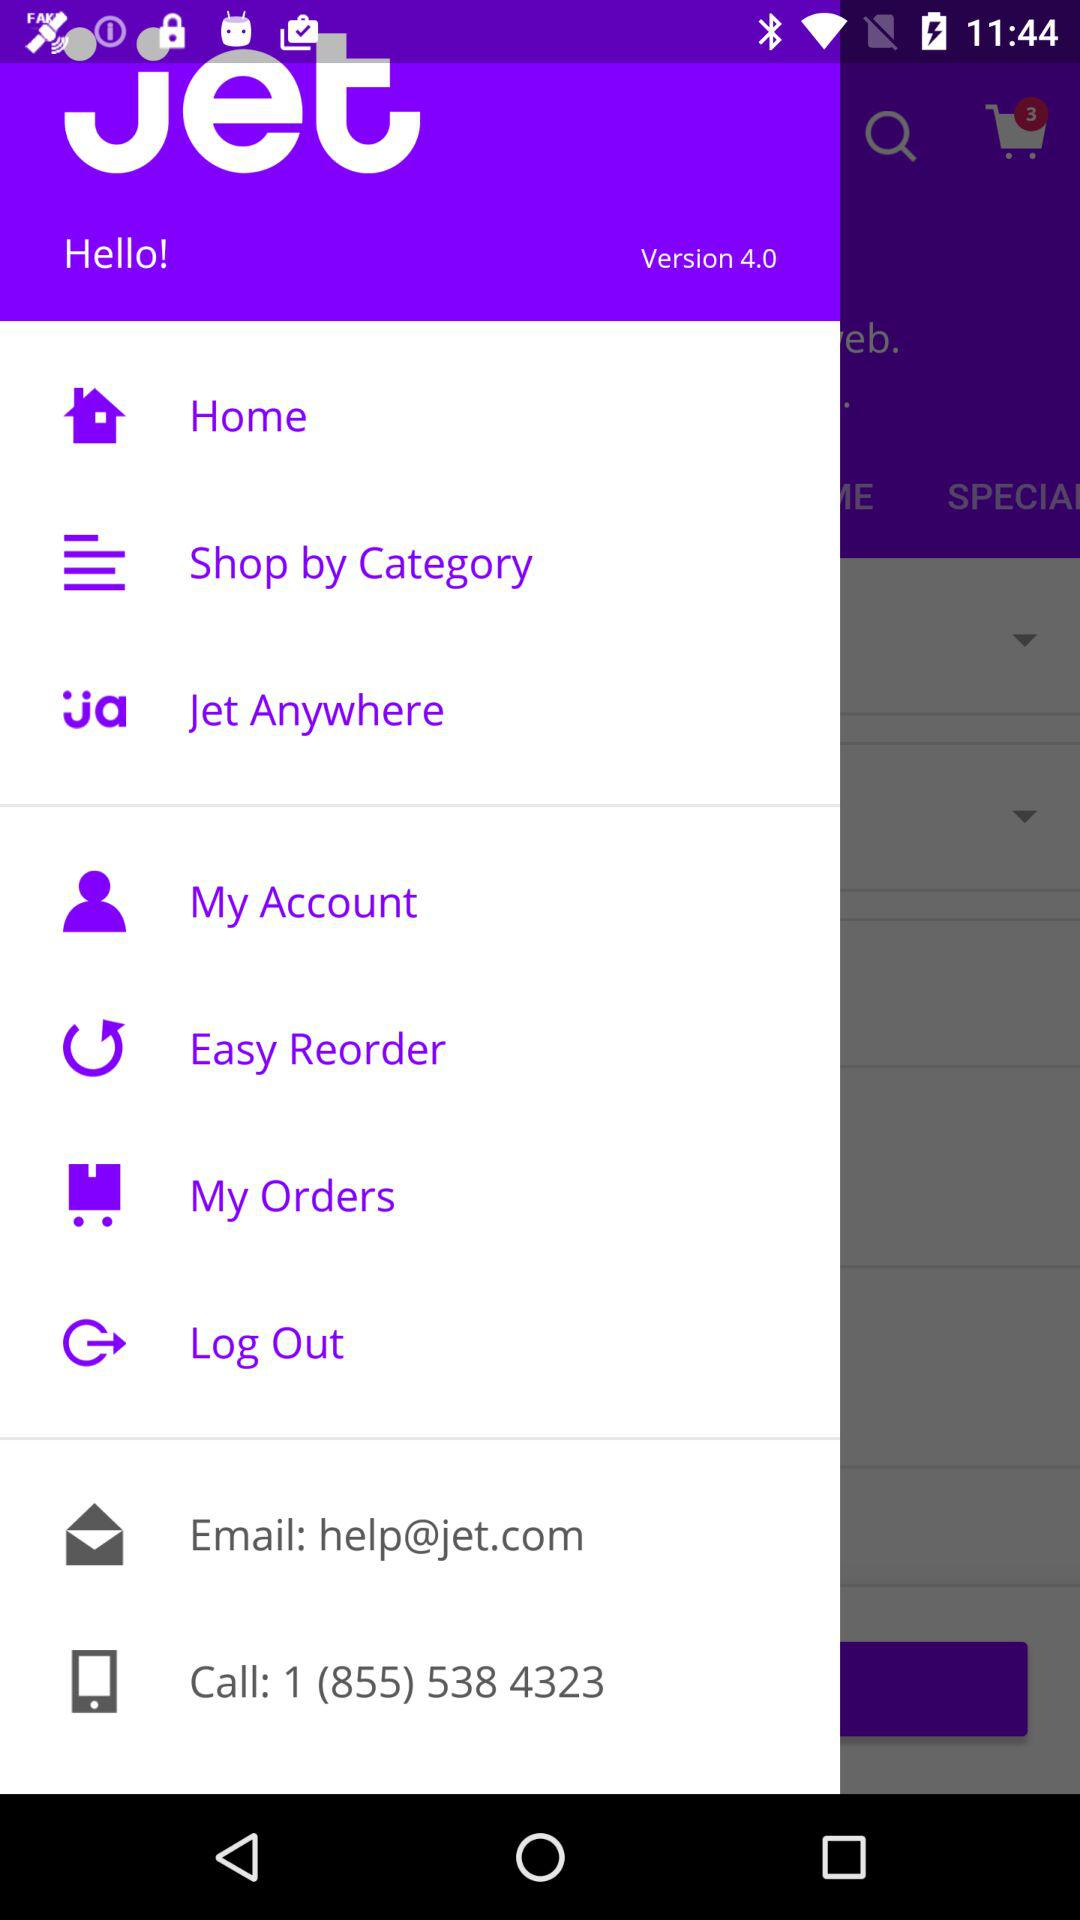What is an email address? The email address is help@jet.com. 